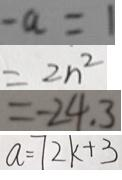<formula> <loc_0><loc_0><loc_500><loc_500>- a = 1 
 = 2 n ^ { 2 } 
 = - 2 4 . 3 
 a = 7 2 k + 3</formula> 